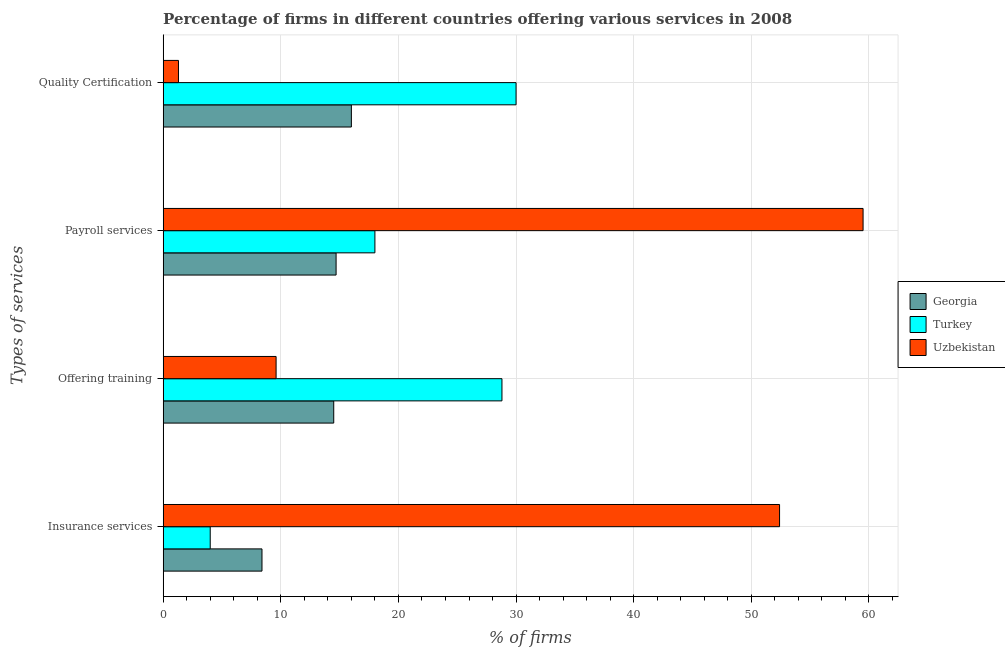How many groups of bars are there?
Offer a very short reply. 4. Are the number of bars on each tick of the Y-axis equal?
Provide a short and direct response. Yes. How many bars are there on the 3rd tick from the bottom?
Your answer should be compact. 3. What is the label of the 1st group of bars from the top?
Your answer should be very brief. Quality Certification. What is the percentage of firms offering training in Turkey?
Make the answer very short. 28.8. Across all countries, what is the maximum percentage of firms offering payroll services?
Your response must be concise. 59.5. Across all countries, what is the minimum percentage of firms offering payroll services?
Your answer should be very brief. 14.7. In which country was the percentage of firms offering insurance services maximum?
Keep it short and to the point. Uzbekistan. In which country was the percentage of firms offering quality certification minimum?
Provide a succinct answer. Uzbekistan. What is the total percentage of firms offering payroll services in the graph?
Make the answer very short. 92.2. What is the difference between the percentage of firms offering payroll services in Uzbekistan and that in Georgia?
Make the answer very short. 44.8. What is the difference between the percentage of firms offering payroll services in Georgia and the percentage of firms offering insurance services in Turkey?
Your answer should be compact. 10.7. What is the average percentage of firms offering payroll services per country?
Ensure brevity in your answer.  30.73. What is the difference between the percentage of firms offering insurance services and percentage of firms offering quality certification in Uzbekistan?
Make the answer very short. 51.1. What is the ratio of the percentage of firms offering quality certification in Uzbekistan to that in Georgia?
Make the answer very short. 0.08. Is the percentage of firms offering insurance services in Uzbekistan less than that in Georgia?
Provide a succinct answer. No. Is the difference between the percentage of firms offering payroll services in Turkey and Uzbekistan greater than the difference between the percentage of firms offering training in Turkey and Uzbekistan?
Give a very brief answer. No. What is the difference between the highest and the lowest percentage of firms offering insurance services?
Offer a terse response. 48.4. In how many countries, is the percentage of firms offering quality certification greater than the average percentage of firms offering quality certification taken over all countries?
Offer a very short reply. 2. Is it the case that in every country, the sum of the percentage of firms offering payroll services and percentage of firms offering training is greater than the sum of percentage of firms offering insurance services and percentage of firms offering quality certification?
Give a very brief answer. No. What does the 3rd bar from the top in Payroll services represents?
Make the answer very short. Georgia. What does the 3rd bar from the bottom in Insurance services represents?
Your answer should be very brief. Uzbekistan. Are all the bars in the graph horizontal?
Your answer should be very brief. Yes. How many countries are there in the graph?
Offer a terse response. 3. Are the values on the major ticks of X-axis written in scientific E-notation?
Make the answer very short. No. Does the graph contain any zero values?
Your answer should be compact. No. Does the graph contain grids?
Your answer should be compact. Yes. Where does the legend appear in the graph?
Your response must be concise. Center right. How many legend labels are there?
Give a very brief answer. 3. How are the legend labels stacked?
Provide a succinct answer. Vertical. What is the title of the graph?
Offer a terse response. Percentage of firms in different countries offering various services in 2008. What is the label or title of the X-axis?
Offer a very short reply. % of firms. What is the label or title of the Y-axis?
Provide a succinct answer. Types of services. What is the % of firms in Georgia in Insurance services?
Your answer should be very brief. 8.4. What is the % of firms of Turkey in Insurance services?
Keep it short and to the point. 4. What is the % of firms of Uzbekistan in Insurance services?
Your response must be concise. 52.4. What is the % of firms of Georgia in Offering training?
Offer a very short reply. 14.5. What is the % of firms of Turkey in Offering training?
Offer a very short reply. 28.8. What is the % of firms of Uzbekistan in Payroll services?
Provide a succinct answer. 59.5. What is the % of firms in Uzbekistan in Quality Certification?
Offer a very short reply. 1.3. Across all Types of services, what is the maximum % of firms of Georgia?
Make the answer very short. 16. Across all Types of services, what is the maximum % of firms of Turkey?
Your answer should be compact. 30. Across all Types of services, what is the maximum % of firms in Uzbekistan?
Ensure brevity in your answer.  59.5. Across all Types of services, what is the minimum % of firms in Georgia?
Provide a succinct answer. 8.4. Across all Types of services, what is the minimum % of firms of Turkey?
Offer a terse response. 4. What is the total % of firms of Georgia in the graph?
Make the answer very short. 53.6. What is the total % of firms of Turkey in the graph?
Offer a terse response. 80.8. What is the total % of firms of Uzbekistan in the graph?
Ensure brevity in your answer.  122.8. What is the difference between the % of firms of Georgia in Insurance services and that in Offering training?
Your answer should be compact. -6.1. What is the difference between the % of firms in Turkey in Insurance services and that in Offering training?
Ensure brevity in your answer.  -24.8. What is the difference between the % of firms of Uzbekistan in Insurance services and that in Offering training?
Offer a terse response. 42.8. What is the difference between the % of firms in Georgia in Insurance services and that in Quality Certification?
Your answer should be compact. -7.6. What is the difference between the % of firms of Turkey in Insurance services and that in Quality Certification?
Your answer should be compact. -26. What is the difference between the % of firms in Uzbekistan in Insurance services and that in Quality Certification?
Give a very brief answer. 51.1. What is the difference between the % of firms of Georgia in Offering training and that in Payroll services?
Your answer should be very brief. -0.2. What is the difference between the % of firms in Turkey in Offering training and that in Payroll services?
Make the answer very short. 10.8. What is the difference between the % of firms of Uzbekistan in Offering training and that in Payroll services?
Keep it short and to the point. -49.9. What is the difference between the % of firms of Uzbekistan in Offering training and that in Quality Certification?
Keep it short and to the point. 8.3. What is the difference between the % of firms of Turkey in Payroll services and that in Quality Certification?
Your response must be concise. -12. What is the difference between the % of firms in Uzbekistan in Payroll services and that in Quality Certification?
Make the answer very short. 58.2. What is the difference between the % of firms of Georgia in Insurance services and the % of firms of Turkey in Offering training?
Ensure brevity in your answer.  -20.4. What is the difference between the % of firms in Turkey in Insurance services and the % of firms in Uzbekistan in Offering training?
Offer a terse response. -5.6. What is the difference between the % of firms of Georgia in Insurance services and the % of firms of Uzbekistan in Payroll services?
Make the answer very short. -51.1. What is the difference between the % of firms of Turkey in Insurance services and the % of firms of Uzbekistan in Payroll services?
Offer a terse response. -55.5. What is the difference between the % of firms in Georgia in Insurance services and the % of firms in Turkey in Quality Certification?
Keep it short and to the point. -21.6. What is the difference between the % of firms in Turkey in Insurance services and the % of firms in Uzbekistan in Quality Certification?
Provide a short and direct response. 2.7. What is the difference between the % of firms of Georgia in Offering training and the % of firms of Turkey in Payroll services?
Give a very brief answer. -3.5. What is the difference between the % of firms in Georgia in Offering training and the % of firms in Uzbekistan in Payroll services?
Your response must be concise. -45. What is the difference between the % of firms of Turkey in Offering training and the % of firms of Uzbekistan in Payroll services?
Your response must be concise. -30.7. What is the difference between the % of firms in Georgia in Offering training and the % of firms in Turkey in Quality Certification?
Give a very brief answer. -15.5. What is the difference between the % of firms of Georgia in Offering training and the % of firms of Uzbekistan in Quality Certification?
Your answer should be very brief. 13.2. What is the difference between the % of firms of Georgia in Payroll services and the % of firms of Turkey in Quality Certification?
Your answer should be very brief. -15.3. What is the difference between the % of firms of Georgia in Payroll services and the % of firms of Uzbekistan in Quality Certification?
Your response must be concise. 13.4. What is the average % of firms in Turkey per Types of services?
Your answer should be very brief. 20.2. What is the average % of firms of Uzbekistan per Types of services?
Give a very brief answer. 30.7. What is the difference between the % of firms of Georgia and % of firms of Turkey in Insurance services?
Your answer should be compact. 4.4. What is the difference between the % of firms in Georgia and % of firms in Uzbekistan in Insurance services?
Your response must be concise. -44. What is the difference between the % of firms of Turkey and % of firms of Uzbekistan in Insurance services?
Provide a short and direct response. -48.4. What is the difference between the % of firms in Georgia and % of firms in Turkey in Offering training?
Provide a succinct answer. -14.3. What is the difference between the % of firms of Georgia and % of firms of Uzbekistan in Offering training?
Make the answer very short. 4.9. What is the difference between the % of firms in Georgia and % of firms in Uzbekistan in Payroll services?
Your answer should be very brief. -44.8. What is the difference between the % of firms in Turkey and % of firms in Uzbekistan in Payroll services?
Your answer should be very brief. -41.5. What is the difference between the % of firms in Georgia and % of firms in Turkey in Quality Certification?
Offer a very short reply. -14. What is the difference between the % of firms of Turkey and % of firms of Uzbekistan in Quality Certification?
Your answer should be compact. 28.7. What is the ratio of the % of firms of Georgia in Insurance services to that in Offering training?
Provide a short and direct response. 0.58. What is the ratio of the % of firms of Turkey in Insurance services to that in Offering training?
Offer a terse response. 0.14. What is the ratio of the % of firms in Uzbekistan in Insurance services to that in Offering training?
Make the answer very short. 5.46. What is the ratio of the % of firms of Turkey in Insurance services to that in Payroll services?
Offer a very short reply. 0.22. What is the ratio of the % of firms of Uzbekistan in Insurance services to that in Payroll services?
Give a very brief answer. 0.88. What is the ratio of the % of firms in Georgia in Insurance services to that in Quality Certification?
Ensure brevity in your answer.  0.53. What is the ratio of the % of firms in Turkey in Insurance services to that in Quality Certification?
Your answer should be very brief. 0.13. What is the ratio of the % of firms of Uzbekistan in Insurance services to that in Quality Certification?
Offer a terse response. 40.31. What is the ratio of the % of firms in Georgia in Offering training to that in Payroll services?
Your response must be concise. 0.99. What is the ratio of the % of firms in Uzbekistan in Offering training to that in Payroll services?
Your answer should be compact. 0.16. What is the ratio of the % of firms of Georgia in Offering training to that in Quality Certification?
Provide a succinct answer. 0.91. What is the ratio of the % of firms in Uzbekistan in Offering training to that in Quality Certification?
Provide a short and direct response. 7.38. What is the ratio of the % of firms of Georgia in Payroll services to that in Quality Certification?
Provide a succinct answer. 0.92. What is the ratio of the % of firms in Turkey in Payroll services to that in Quality Certification?
Provide a short and direct response. 0.6. What is the ratio of the % of firms in Uzbekistan in Payroll services to that in Quality Certification?
Ensure brevity in your answer.  45.77. What is the difference between the highest and the lowest % of firms in Georgia?
Give a very brief answer. 7.6. What is the difference between the highest and the lowest % of firms of Uzbekistan?
Offer a terse response. 58.2. 